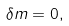<formula> <loc_0><loc_0><loc_500><loc_500>\delta m = 0 ,</formula> 